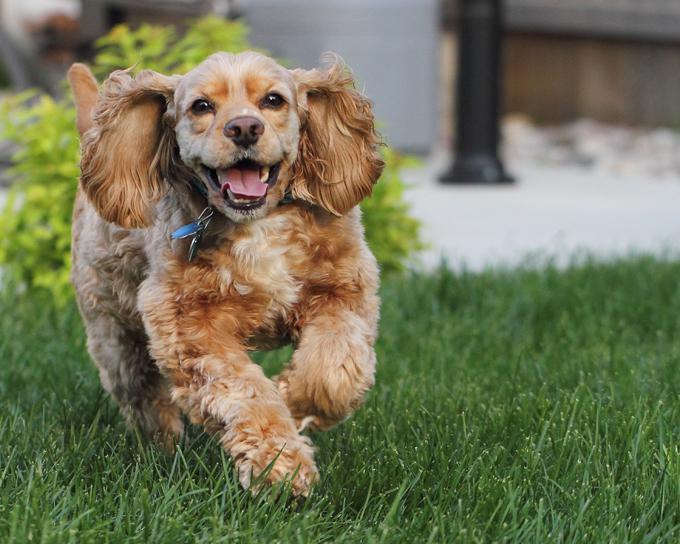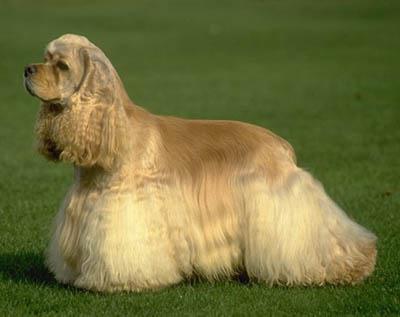The first image is the image on the left, the second image is the image on the right. Evaluate the accuracy of this statement regarding the images: "One image shows a golden-colored cocker spaniel standing on the grass, body turned to the left.". Is it true? Answer yes or no. Yes. The first image is the image on the left, the second image is the image on the right. Analyze the images presented: Is the assertion "One dog is sitting down while the other dog is standing on all fours" valid? Answer yes or no. No. 